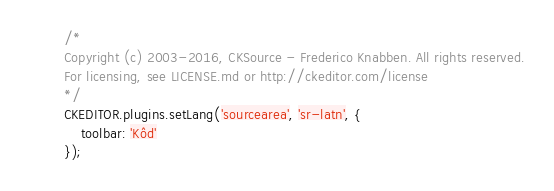Convert code to text. <code><loc_0><loc_0><loc_500><loc_500><_JavaScript_>/*
Copyright (c) 2003-2016, CKSource - Frederico Knabben. All rights reserved.
For licensing, see LICENSE.md or http://ckeditor.com/license
*/
CKEDITOR.plugins.setLang('sourcearea', 'sr-latn', {
    toolbar: 'Kôd'
});
</code> 